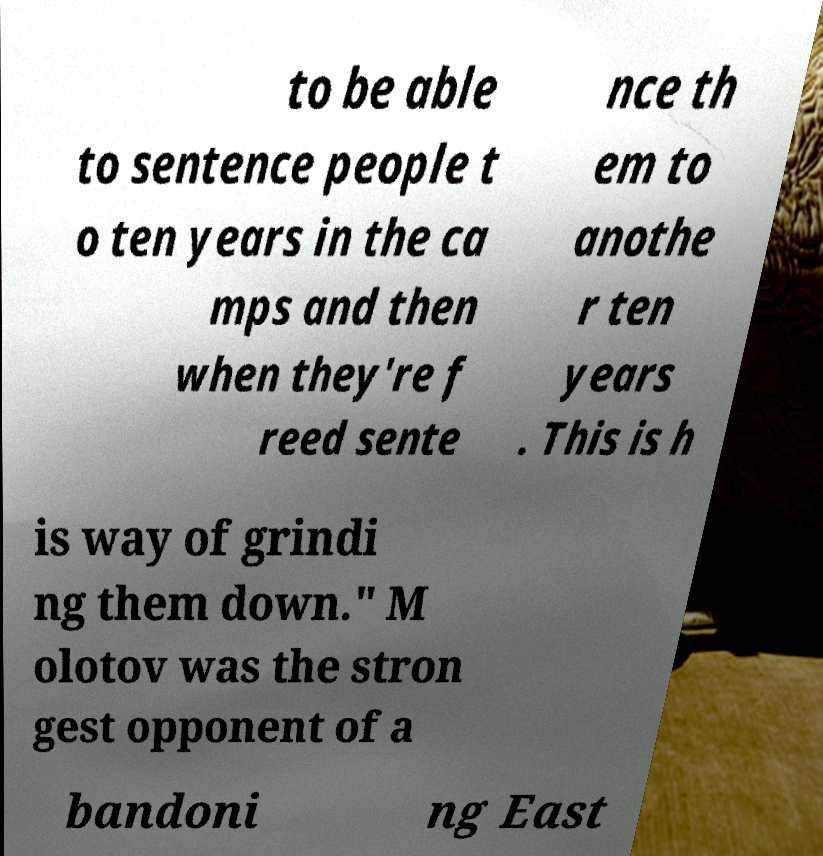Can you read and provide the text displayed in the image?This photo seems to have some interesting text. Can you extract and type it out for me? to be able to sentence people t o ten years in the ca mps and then when they're f reed sente nce th em to anothe r ten years . This is h is way of grindi ng them down." M olotov was the stron gest opponent of a bandoni ng East 